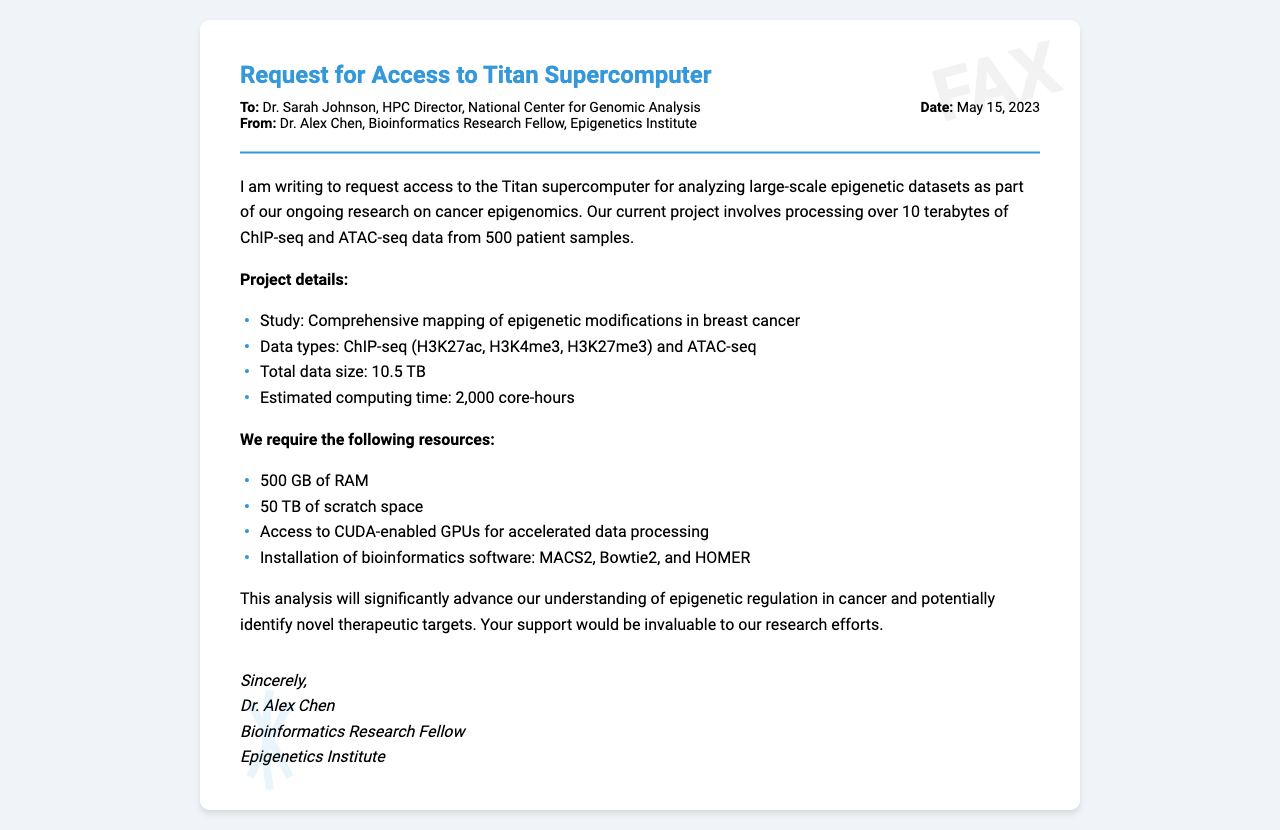What is the title of the request? The title of the request is mentioned at the top of the fax document.
Answer: Request for Access to Titan Supercomputer Who is the recipient of the fax? The recipient is addressed in the header section of the document.
Answer: Dr. Sarah Johnson What is the date of the fax? The date is specified in the header information.
Answer: May 15, 2023 What is the total data size mentioned in the project details? The total data size is provided in the body of the document under project details.
Answer: 10.5 TB What type of data is being analyzed? The types of data are listed in the project details of the document.
Answer: ChIP-seq and ATAC-seq How many patient samples are involved in the analysis? The number of patient samples is mentioned in the introduction of the document.
Answer: 500 What is the estimated computing time for the project? The estimated computing time is listed in the project details section.
Answer: 2,000 core-hours What resources are requested for the analysis? The resources are outlined in the body of the document under requirements.
Answer: 500 GB of RAM, 50 TB of scratch space, GPUs, bioinformatics software Why is the analysis important according to the document? The importance of the analysis is discussed towards the end of the body content.
Answer: Advance understanding of epigenetic regulation in cancer 